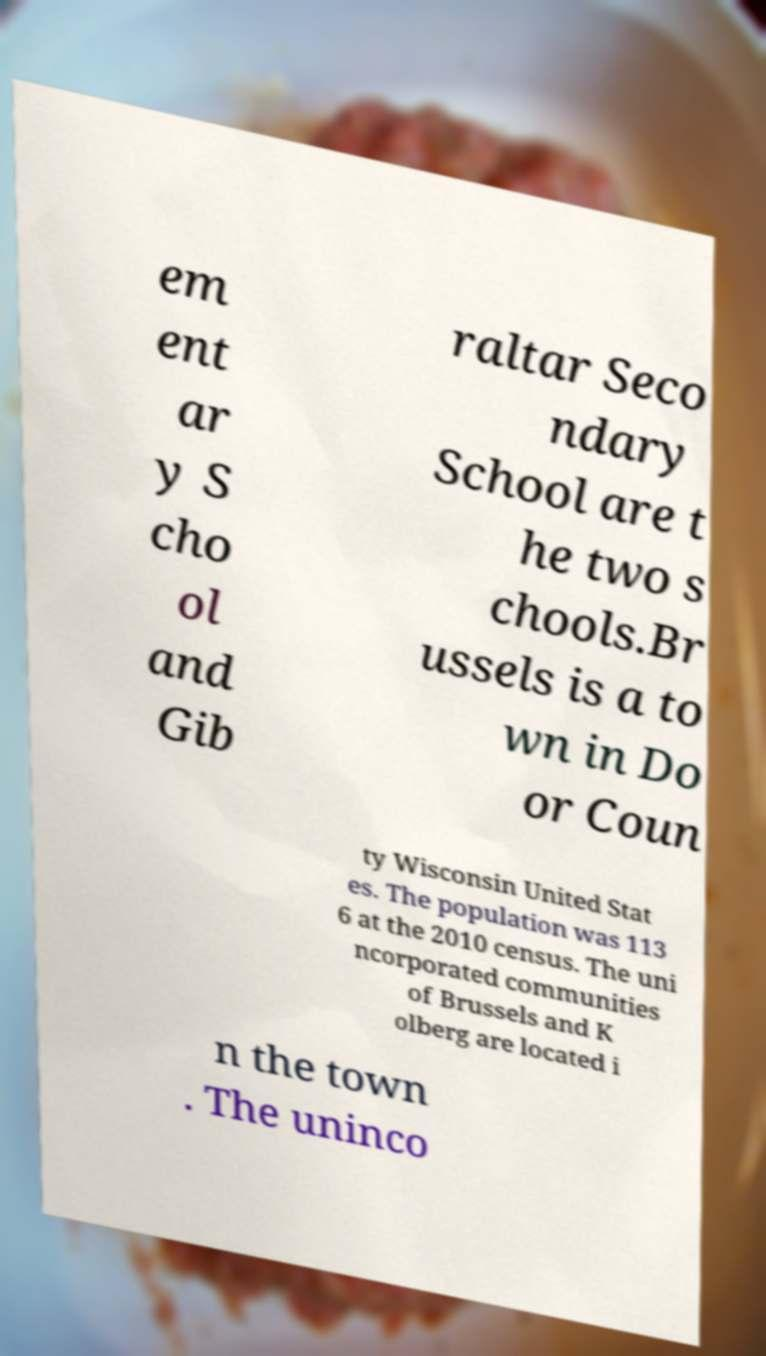There's text embedded in this image that I need extracted. Can you transcribe it verbatim? em ent ar y S cho ol and Gib raltar Seco ndary School are t he two s chools.Br ussels is a to wn in Do or Coun ty Wisconsin United Stat es. The population was 113 6 at the 2010 census. The uni ncorporated communities of Brussels and K olberg are located i n the town . The uninco 